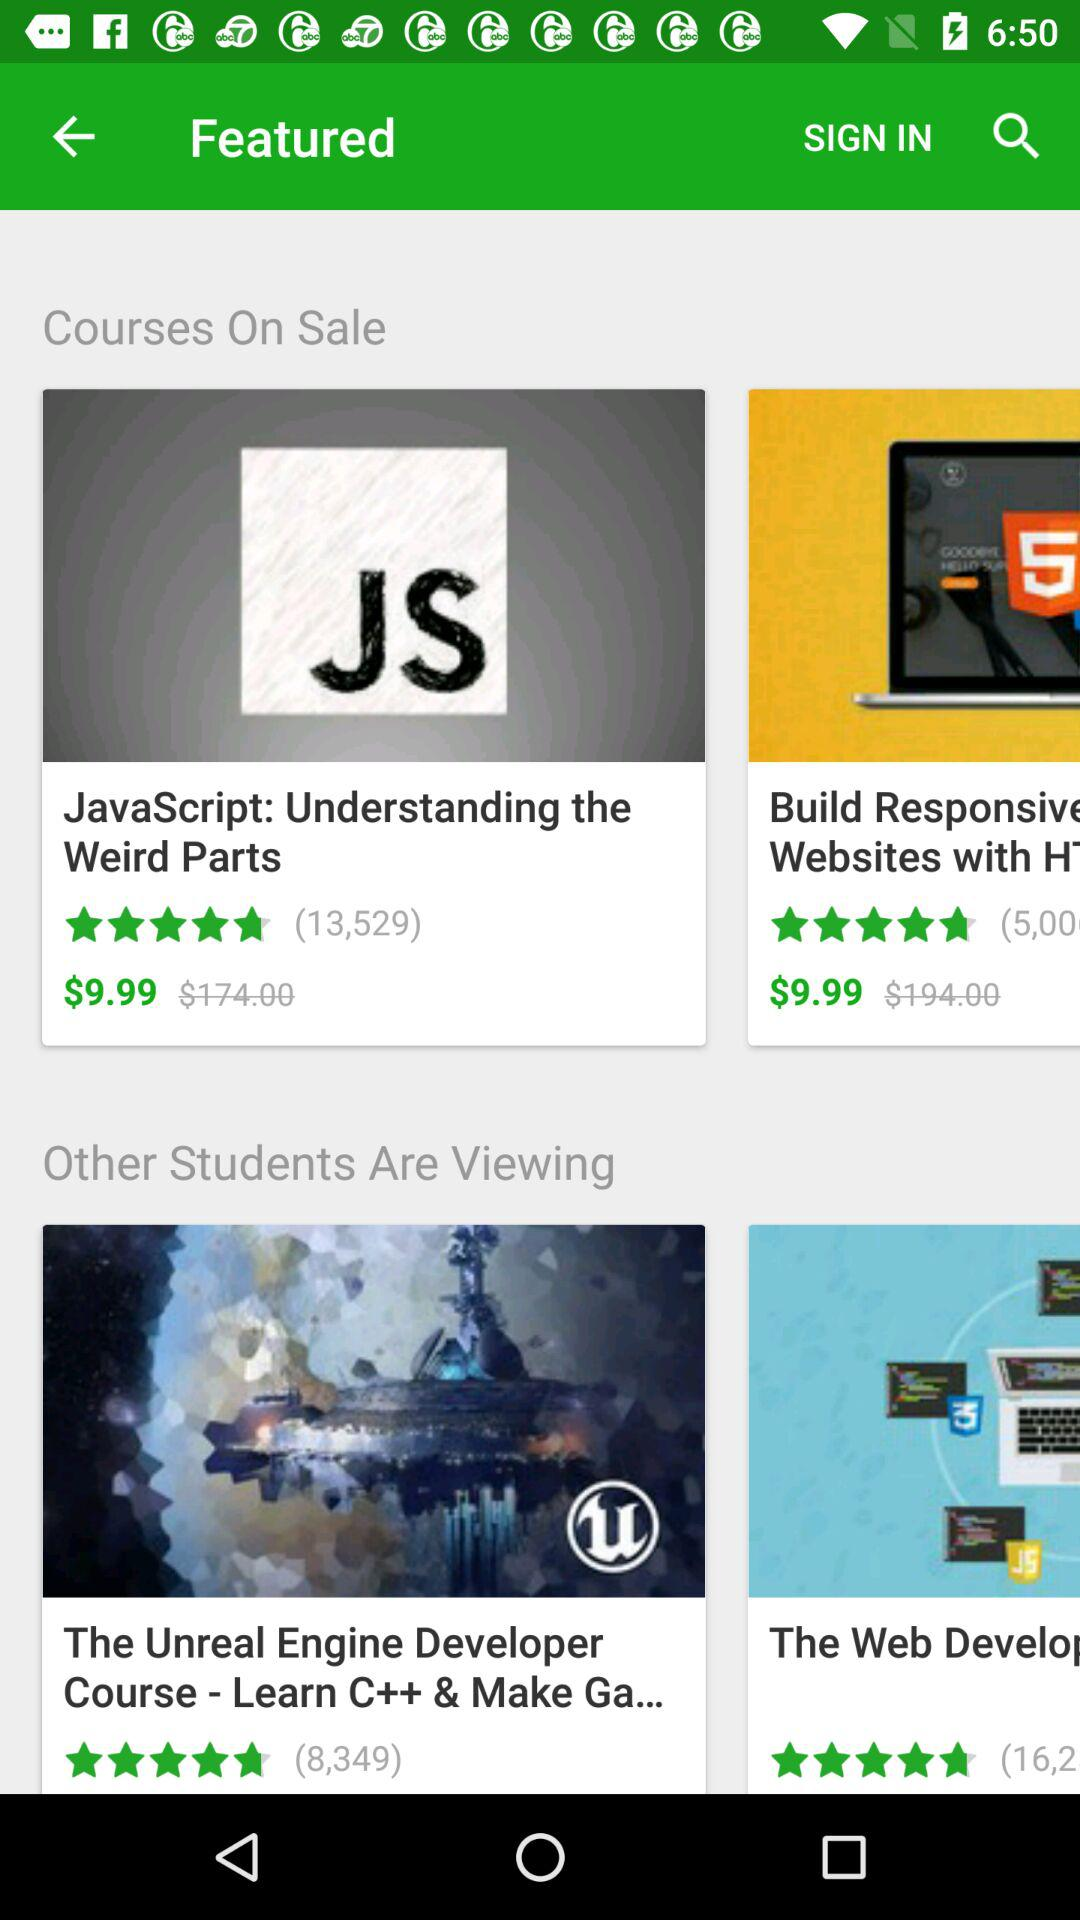What is the rating of the "Unreal Engine Developer Course-Learn C++ & Make Ga..."? The rating is 5 stars. 